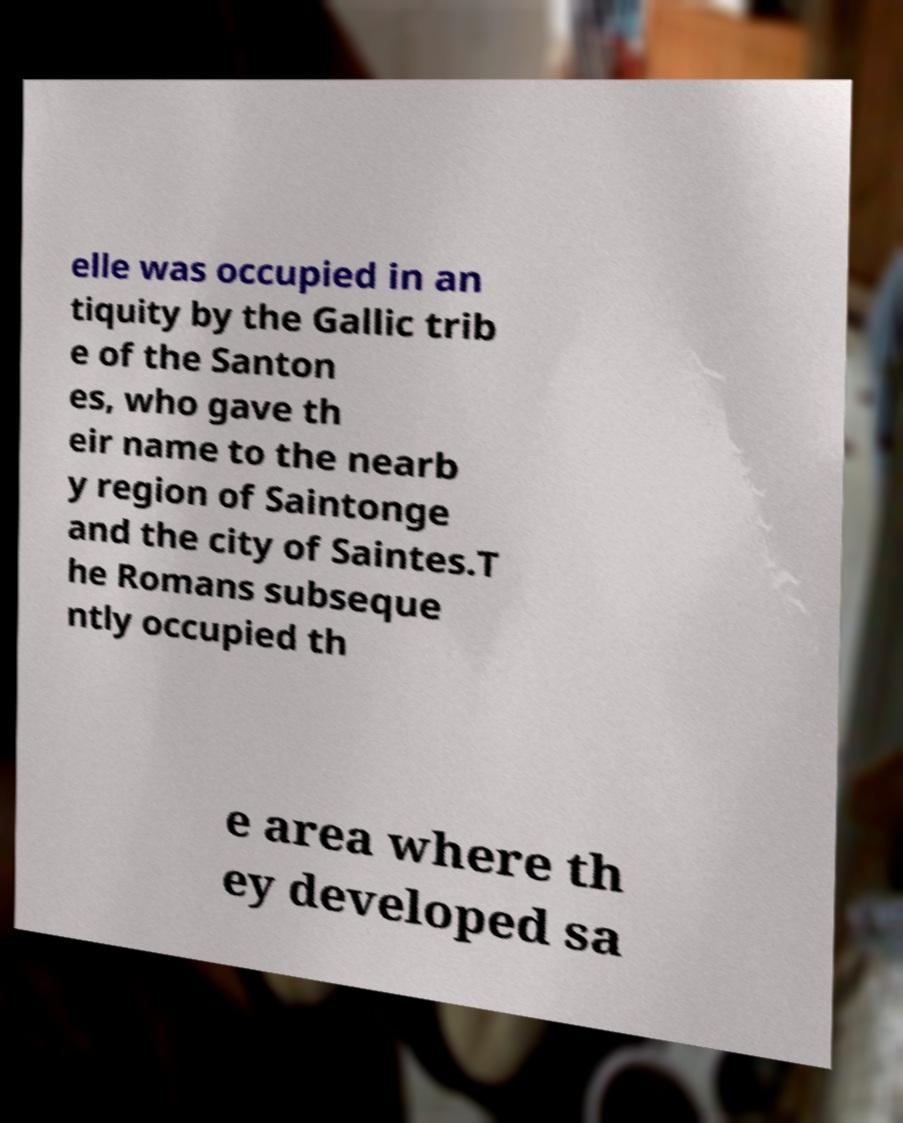There's text embedded in this image that I need extracted. Can you transcribe it verbatim? elle was occupied in an tiquity by the Gallic trib e of the Santon es, who gave th eir name to the nearb y region of Saintonge and the city of Saintes.T he Romans subseque ntly occupied th e area where th ey developed sa 